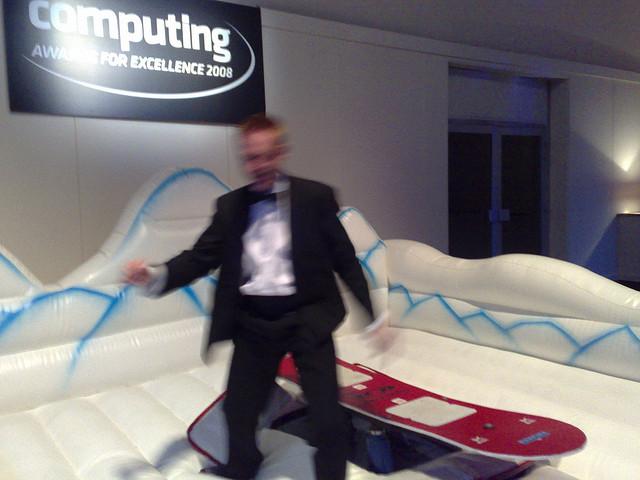Is this public transit?
Quick response, please. No. Is this man wearing a suit?
Keep it brief. Yes. What is the man doing?
Concise answer only. Jumping. What color is the skateboard?
Give a very brief answer. Red. 